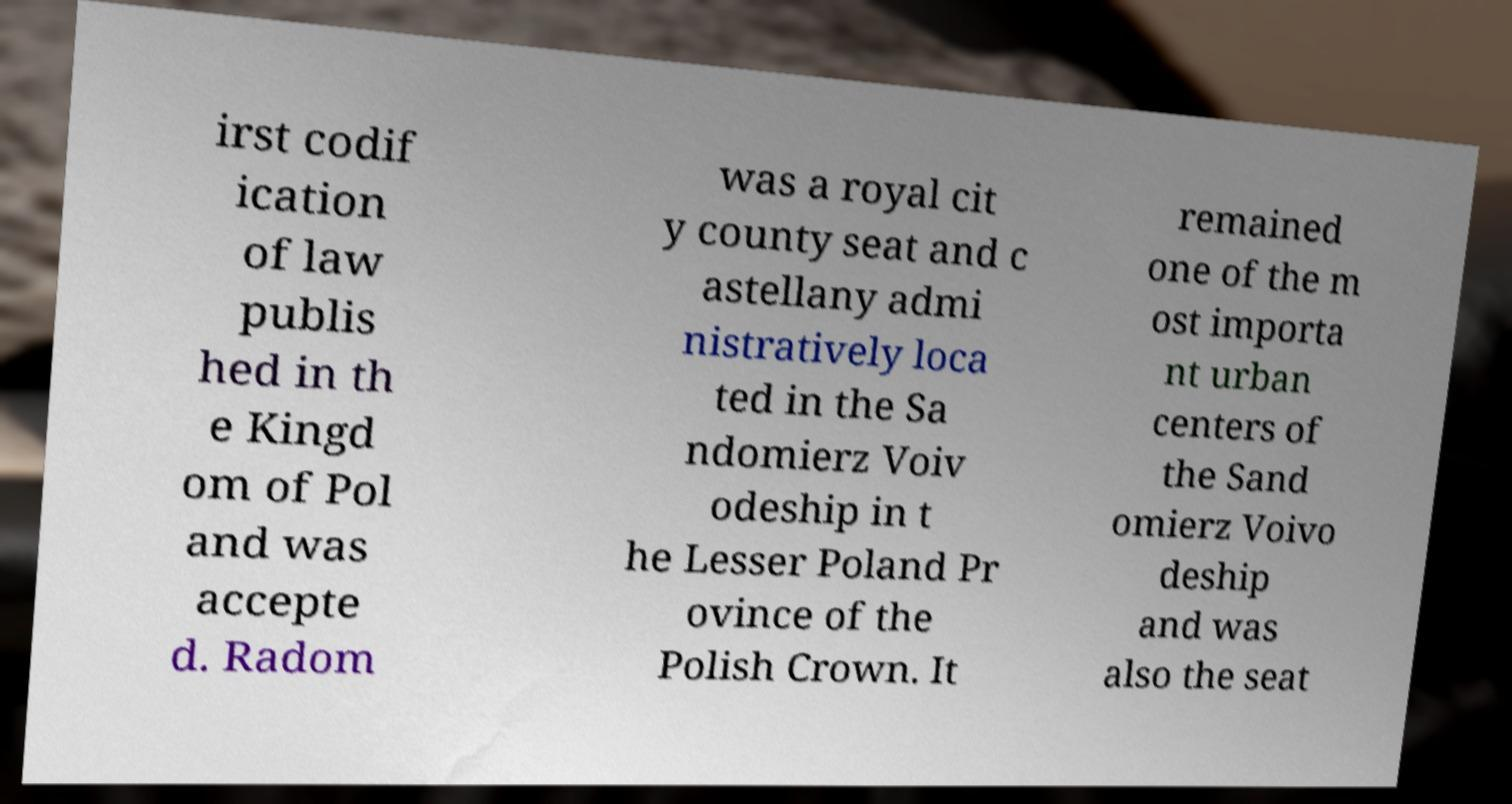Could you assist in decoding the text presented in this image and type it out clearly? irst codif ication of law publis hed in th e Kingd om of Pol and was accepte d. Radom was a royal cit y county seat and c astellany admi nistratively loca ted in the Sa ndomierz Voiv odeship in t he Lesser Poland Pr ovince of the Polish Crown. It remained one of the m ost importa nt urban centers of the Sand omierz Voivo deship and was also the seat 